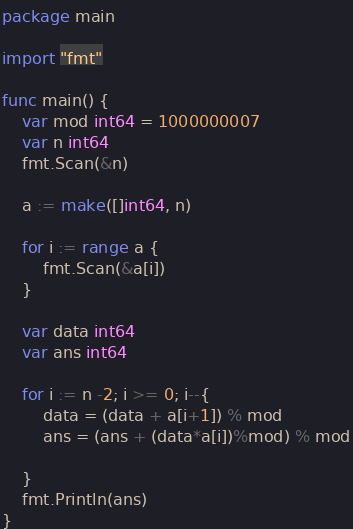<code> <loc_0><loc_0><loc_500><loc_500><_Go_>package main
 
import "fmt"
 
func main() {
	var mod int64 = 1000000007
	var n int64
	fmt.Scan(&n)
 
	a := make([]int64, n)
 
	for i := range a {
		fmt.Scan(&a[i])
	}
 
	var data int64
	var ans int64
 
	for i := n -2; i >= 0; i--{
		data = (data + a[i+1]) % mod
		ans = (ans + (data*a[i])%mod) % mod
 
	}
	fmt.Println(ans)
}</code> 